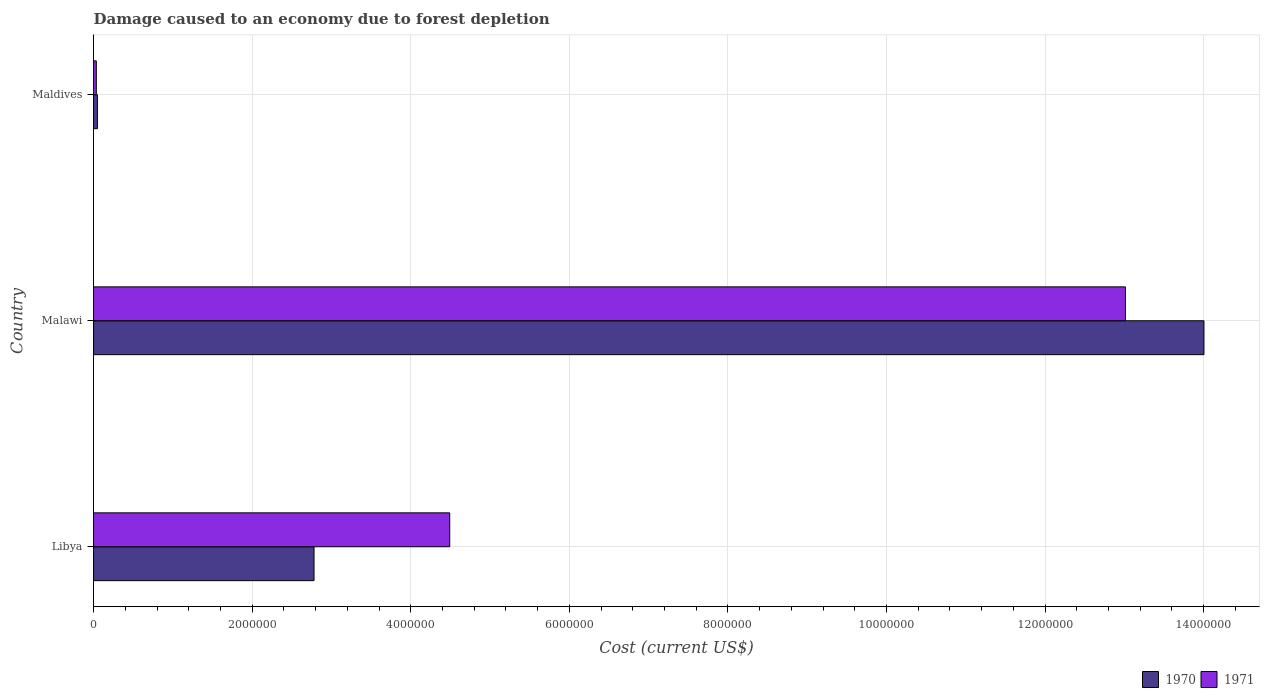How many different coloured bars are there?
Offer a very short reply. 2. Are the number of bars on each tick of the Y-axis equal?
Your answer should be compact. Yes. How many bars are there on the 1st tick from the top?
Provide a short and direct response. 2. What is the label of the 1st group of bars from the top?
Your answer should be compact. Maldives. In how many cases, is the number of bars for a given country not equal to the number of legend labels?
Provide a short and direct response. 0. What is the cost of damage caused due to forest depletion in 1971 in Libya?
Offer a very short reply. 4.49e+06. Across all countries, what is the maximum cost of damage caused due to forest depletion in 1970?
Your answer should be very brief. 1.40e+07. Across all countries, what is the minimum cost of damage caused due to forest depletion in 1970?
Offer a terse response. 4.86e+04. In which country was the cost of damage caused due to forest depletion in 1970 maximum?
Your answer should be compact. Malawi. In which country was the cost of damage caused due to forest depletion in 1970 minimum?
Ensure brevity in your answer.  Maldives. What is the total cost of damage caused due to forest depletion in 1971 in the graph?
Your answer should be very brief. 1.75e+07. What is the difference between the cost of damage caused due to forest depletion in 1970 in Libya and that in Malawi?
Your response must be concise. -1.12e+07. What is the difference between the cost of damage caused due to forest depletion in 1971 in Libya and the cost of damage caused due to forest depletion in 1970 in Malawi?
Keep it short and to the point. -9.51e+06. What is the average cost of damage caused due to forest depletion in 1971 per country?
Give a very brief answer. 5.85e+06. What is the difference between the cost of damage caused due to forest depletion in 1971 and cost of damage caused due to forest depletion in 1970 in Libya?
Offer a terse response. 1.71e+06. What is the ratio of the cost of damage caused due to forest depletion in 1970 in Libya to that in Maldives?
Ensure brevity in your answer.  57.16. Is the difference between the cost of damage caused due to forest depletion in 1971 in Libya and Maldives greater than the difference between the cost of damage caused due to forest depletion in 1970 in Libya and Maldives?
Make the answer very short. Yes. What is the difference between the highest and the second highest cost of damage caused due to forest depletion in 1971?
Provide a short and direct response. 8.52e+06. What is the difference between the highest and the lowest cost of damage caused due to forest depletion in 1970?
Your response must be concise. 1.40e+07. Is the sum of the cost of damage caused due to forest depletion in 1971 in Libya and Maldives greater than the maximum cost of damage caused due to forest depletion in 1970 across all countries?
Give a very brief answer. No. What does the 2nd bar from the top in Libya represents?
Provide a short and direct response. 1970. What does the 2nd bar from the bottom in Maldives represents?
Your answer should be very brief. 1971. How many bars are there?
Make the answer very short. 6. Are all the bars in the graph horizontal?
Your answer should be compact. Yes. What is the difference between two consecutive major ticks on the X-axis?
Make the answer very short. 2.00e+06. Does the graph contain any zero values?
Your response must be concise. No. Does the graph contain grids?
Give a very brief answer. Yes. How are the legend labels stacked?
Your response must be concise. Horizontal. What is the title of the graph?
Provide a short and direct response. Damage caused to an economy due to forest depletion. What is the label or title of the X-axis?
Keep it short and to the point. Cost (current US$). What is the Cost (current US$) of 1970 in Libya?
Offer a terse response. 2.78e+06. What is the Cost (current US$) of 1971 in Libya?
Offer a very short reply. 4.49e+06. What is the Cost (current US$) in 1970 in Malawi?
Give a very brief answer. 1.40e+07. What is the Cost (current US$) of 1971 in Malawi?
Provide a succinct answer. 1.30e+07. What is the Cost (current US$) in 1970 in Maldives?
Your answer should be compact. 4.86e+04. What is the Cost (current US$) of 1971 in Maldives?
Your answer should be very brief. 3.48e+04. Across all countries, what is the maximum Cost (current US$) in 1970?
Give a very brief answer. 1.40e+07. Across all countries, what is the maximum Cost (current US$) in 1971?
Your answer should be very brief. 1.30e+07. Across all countries, what is the minimum Cost (current US$) in 1970?
Your answer should be very brief. 4.86e+04. Across all countries, what is the minimum Cost (current US$) of 1971?
Your response must be concise. 3.48e+04. What is the total Cost (current US$) of 1970 in the graph?
Make the answer very short. 1.68e+07. What is the total Cost (current US$) of 1971 in the graph?
Give a very brief answer. 1.75e+07. What is the difference between the Cost (current US$) of 1970 in Libya and that in Malawi?
Ensure brevity in your answer.  -1.12e+07. What is the difference between the Cost (current US$) of 1971 in Libya and that in Malawi?
Offer a very short reply. -8.52e+06. What is the difference between the Cost (current US$) of 1970 in Libya and that in Maldives?
Provide a short and direct response. 2.73e+06. What is the difference between the Cost (current US$) of 1971 in Libya and that in Maldives?
Ensure brevity in your answer.  4.46e+06. What is the difference between the Cost (current US$) in 1970 in Malawi and that in Maldives?
Make the answer very short. 1.40e+07. What is the difference between the Cost (current US$) of 1971 in Malawi and that in Maldives?
Offer a terse response. 1.30e+07. What is the difference between the Cost (current US$) in 1970 in Libya and the Cost (current US$) in 1971 in Malawi?
Provide a short and direct response. -1.02e+07. What is the difference between the Cost (current US$) of 1970 in Libya and the Cost (current US$) of 1971 in Maldives?
Keep it short and to the point. 2.75e+06. What is the difference between the Cost (current US$) in 1970 in Malawi and the Cost (current US$) in 1971 in Maldives?
Keep it short and to the point. 1.40e+07. What is the average Cost (current US$) in 1970 per country?
Your answer should be compact. 5.61e+06. What is the average Cost (current US$) of 1971 per country?
Your answer should be compact. 5.85e+06. What is the difference between the Cost (current US$) in 1970 and Cost (current US$) in 1971 in Libya?
Your answer should be compact. -1.71e+06. What is the difference between the Cost (current US$) in 1970 and Cost (current US$) in 1971 in Malawi?
Your answer should be compact. 9.91e+05. What is the difference between the Cost (current US$) in 1970 and Cost (current US$) in 1971 in Maldives?
Your answer should be compact. 1.39e+04. What is the ratio of the Cost (current US$) in 1970 in Libya to that in Malawi?
Make the answer very short. 0.2. What is the ratio of the Cost (current US$) in 1971 in Libya to that in Malawi?
Your response must be concise. 0.35. What is the ratio of the Cost (current US$) of 1970 in Libya to that in Maldives?
Ensure brevity in your answer.  57.16. What is the ratio of the Cost (current US$) in 1971 in Libya to that in Maldives?
Your answer should be very brief. 129.14. What is the ratio of the Cost (current US$) of 1970 in Malawi to that in Maldives?
Provide a short and direct response. 287.9. What is the ratio of the Cost (current US$) in 1971 in Malawi to that in Maldives?
Offer a very short reply. 374.14. What is the difference between the highest and the second highest Cost (current US$) in 1970?
Your answer should be very brief. 1.12e+07. What is the difference between the highest and the second highest Cost (current US$) in 1971?
Your answer should be compact. 8.52e+06. What is the difference between the highest and the lowest Cost (current US$) in 1970?
Keep it short and to the point. 1.40e+07. What is the difference between the highest and the lowest Cost (current US$) in 1971?
Your answer should be compact. 1.30e+07. 